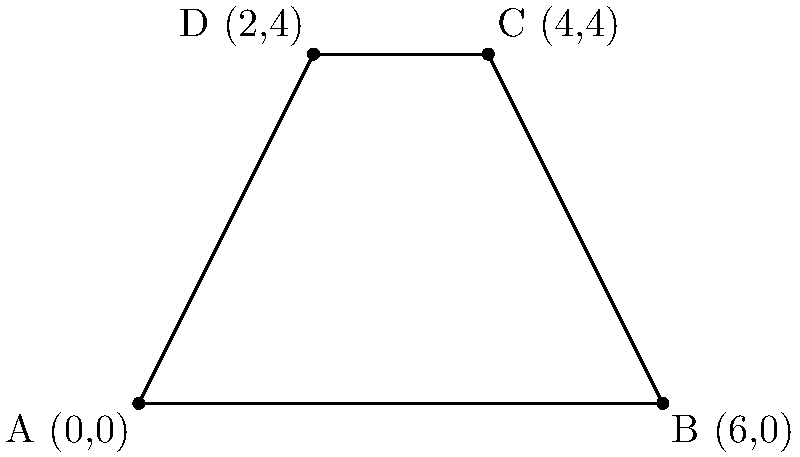As a TSU labor union member in Philadelphia, you're tasked with calculating the area of a potential new union meeting space. The space is represented by a polygon on a coordinate system, with vertices at A(0,0), B(6,0), C(4,4), and D(2,4). Calculate the area of this polygon in square units. To calculate the area of this polygon, we can use the Shoelace formula (also known as the surveyor's formula). The steps are as follows:

1) First, let's list the coordinates in order:
   (0,0), (6,0), (4,4), (2,4)

2) The Shoelace formula is:
   $$Area = \frac{1}{2}|(x_1y_2 + x_2y_3 + x_3y_4 + x_4y_1) - (y_1x_2 + y_2x_3 + y_3x_4 + y_4x_1)|$$

3) Let's substitute our values:
   $$Area = \frac{1}{2}|(0\cdot0 + 6\cdot4 + 4\cdot4 + 2\cdot0) - (0\cdot6 + 0\cdot4 + 4\cdot2 + 4\cdot0)|$$

4) Simplify:
   $$Area = \frac{1}{2}|(0 + 24 + 16 + 0) - (0 + 0 + 8 + 0)|$$
   $$Area = \frac{1}{2}|40 - 8|$$
   $$Area = \frac{1}{2}|32|$$
   $$Area = \frac{1}{2}\cdot32$$
   $$Area = 16$$

Therefore, the area of the polygon is 16 square units.
Answer: 16 square units 